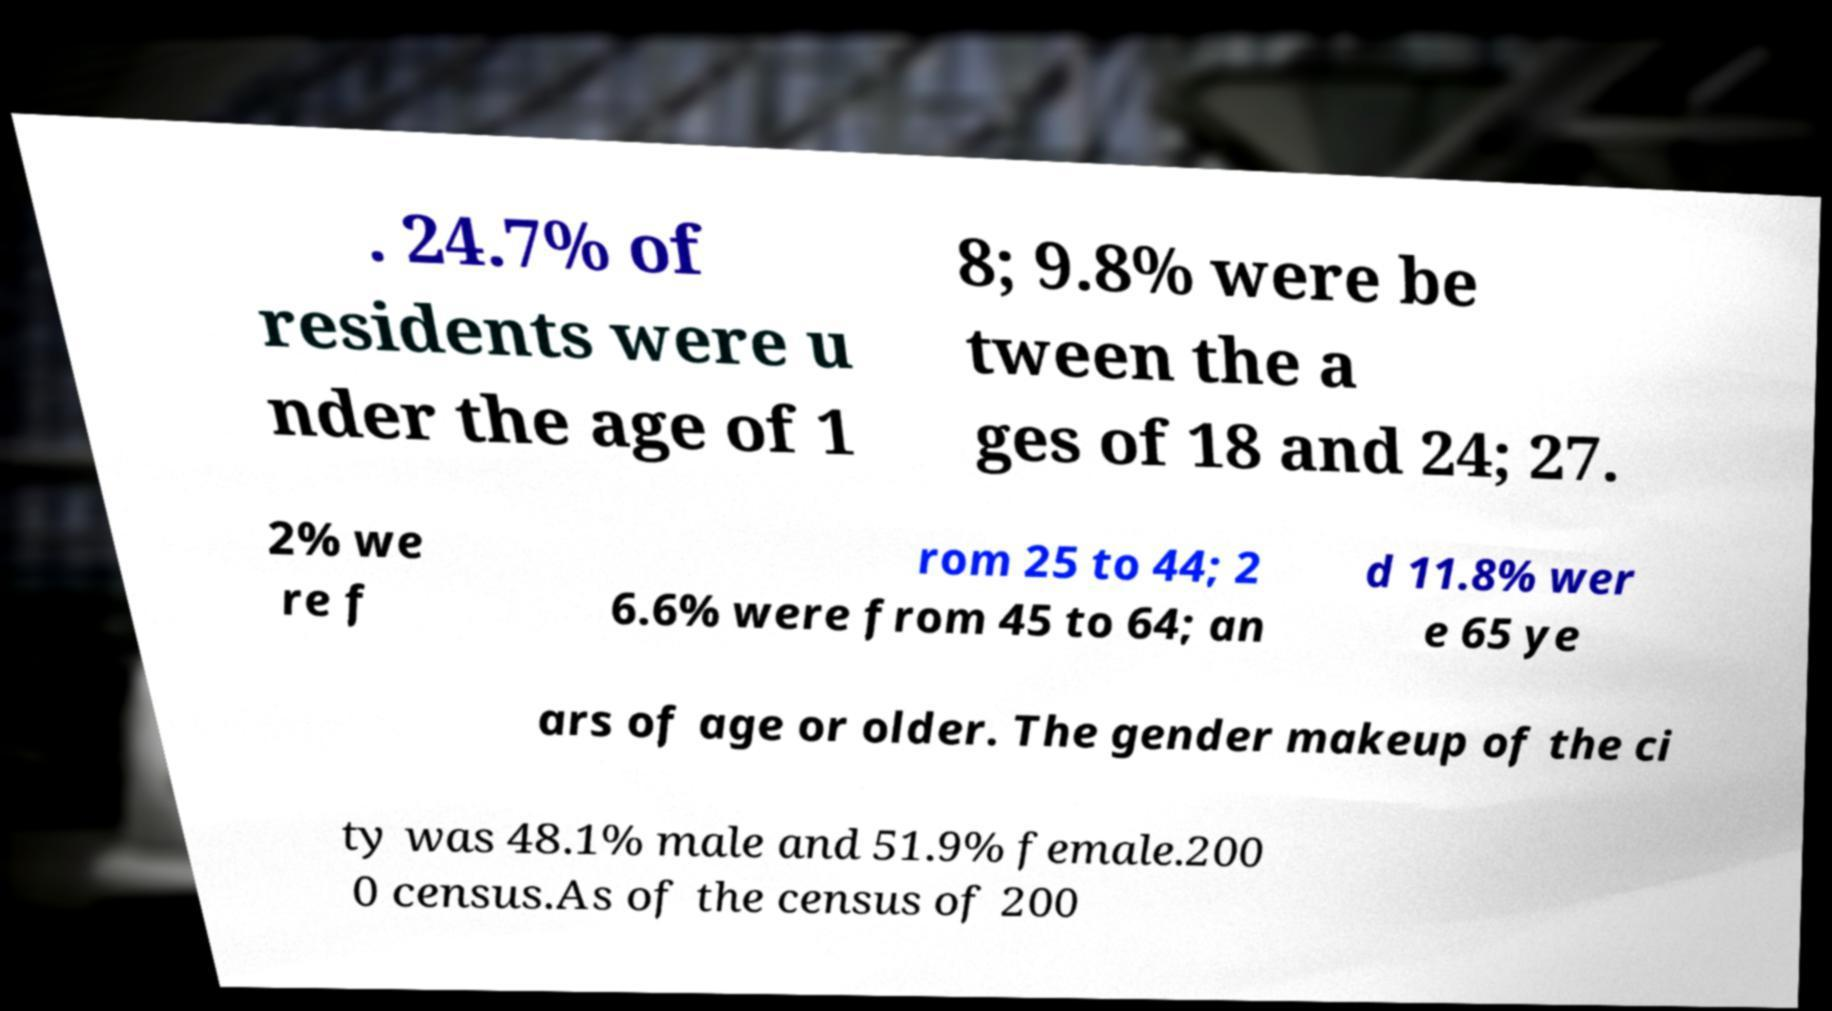Can you read and provide the text displayed in the image?This photo seems to have some interesting text. Can you extract and type it out for me? . 24.7% of residents were u nder the age of 1 8; 9.8% were be tween the a ges of 18 and 24; 27. 2% we re f rom 25 to 44; 2 6.6% were from 45 to 64; an d 11.8% wer e 65 ye ars of age or older. The gender makeup of the ci ty was 48.1% male and 51.9% female.200 0 census.As of the census of 200 